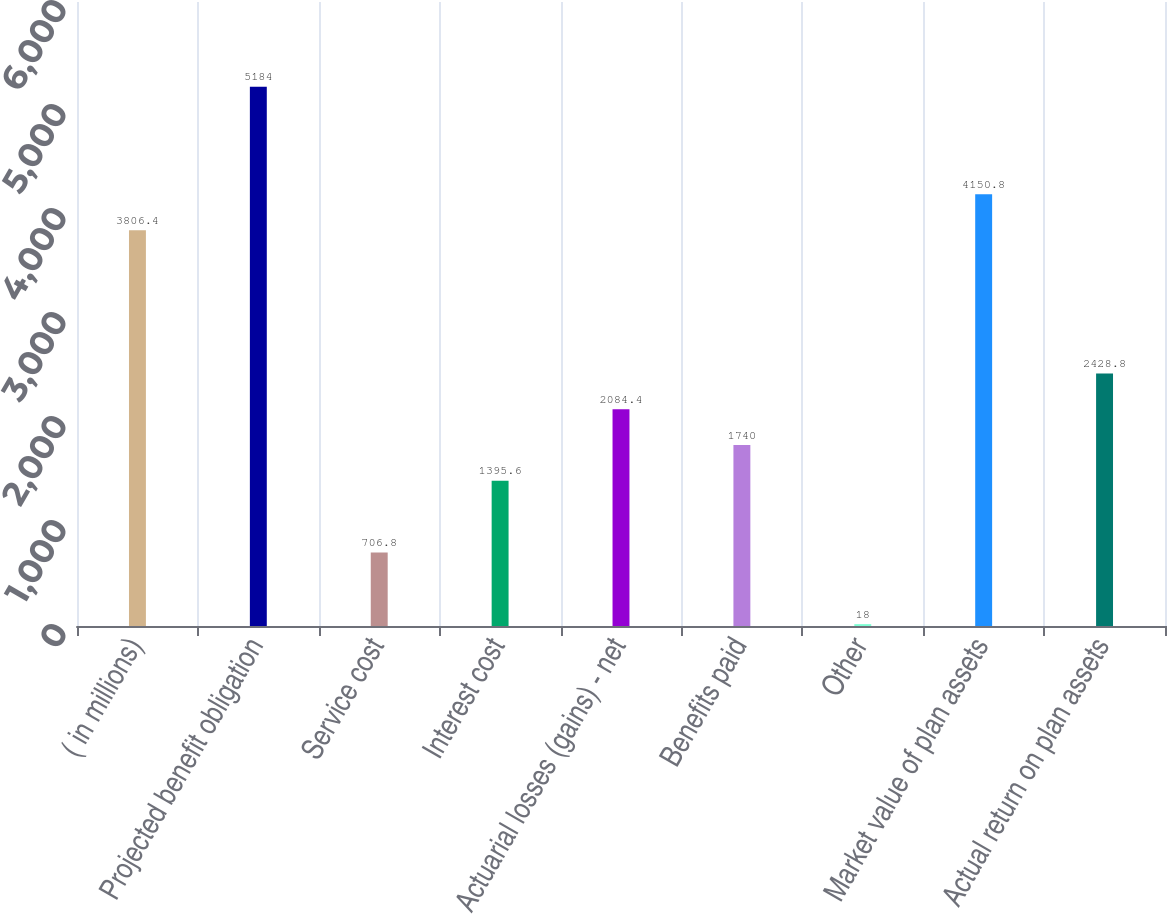<chart> <loc_0><loc_0><loc_500><loc_500><bar_chart><fcel>( in millions)<fcel>Projected benefit obligation<fcel>Service cost<fcel>Interest cost<fcel>Actuarial losses (gains) - net<fcel>Benefits paid<fcel>Other<fcel>Market value of plan assets<fcel>Actual return on plan assets<nl><fcel>3806.4<fcel>5184<fcel>706.8<fcel>1395.6<fcel>2084.4<fcel>1740<fcel>18<fcel>4150.8<fcel>2428.8<nl></chart> 